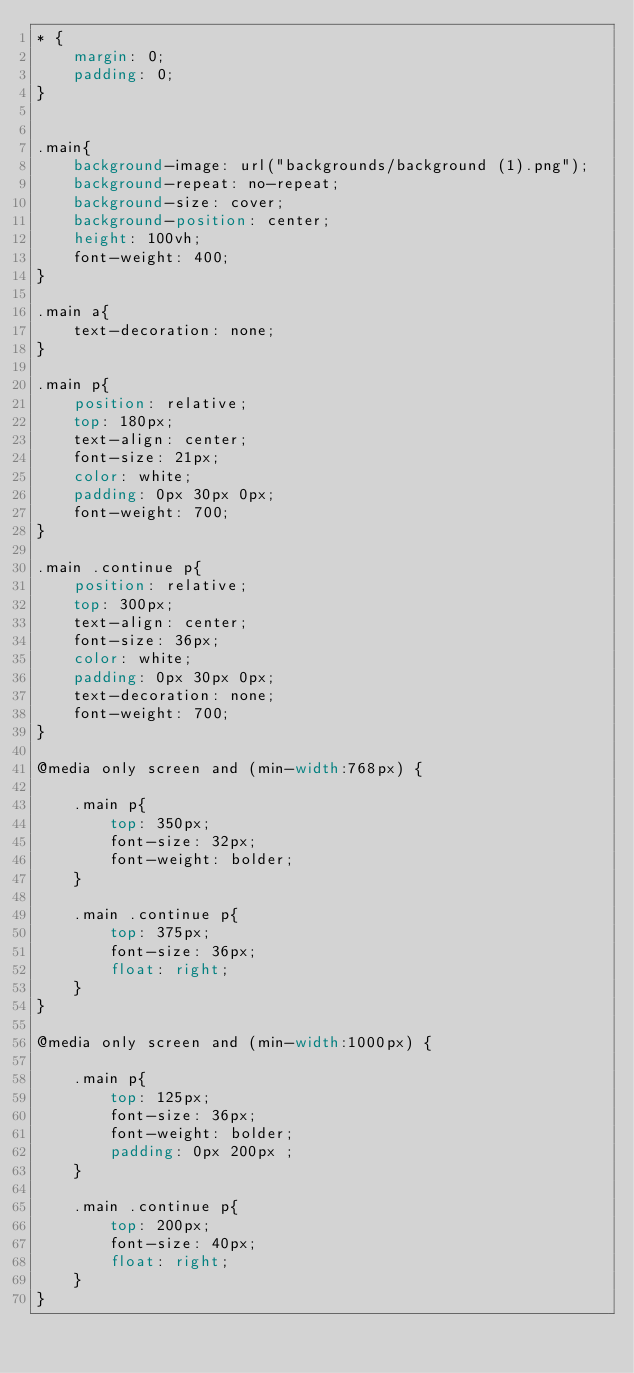Convert code to text. <code><loc_0><loc_0><loc_500><loc_500><_CSS_>* {
    margin: 0;
    padding: 0;
}


.main{
    background-image: url("backgrounds/background (1).png");
    background-repeat: no-repeat;
    background-size: cover;
    background-position: center;
    height: 100vh;
    font-weight: 400;
}

.main a{
    text-decoration: none;
}

.main p{
    position: relative;
    top: 180px;
    text-align: center;
    font-size: 21px;
    color: white;   
    padding: 0px 30px 0px;
    font-weight: 700;
}

.main .continue p{
    position: relative;
    top: 300px;
    text-align: center;
    font-size: 36px;
    color: white;   
    padding: 0px 30px 0px;
    text-decoration: none;
    font-weight: 700;
}

@media only screen and (min-width:768px) {

    .main p{
        top: 350px;
        font-size: 32px;
        font-weight: bolder;
    }
    
    .main .continue p{
        top: 375px;
        font-size: 36px;
        float: right;
    }
}

@media only screen and (min-width:1000px) {
    
    .main p{
        top: 125px;
        font-size: 36px;
        font-weight: bolder;
        padding: 0px 200px ;
    }
    
    .main .continue p{
        top: 200px;
        font-size: 40px;
        float: right;
    }
}</code> 